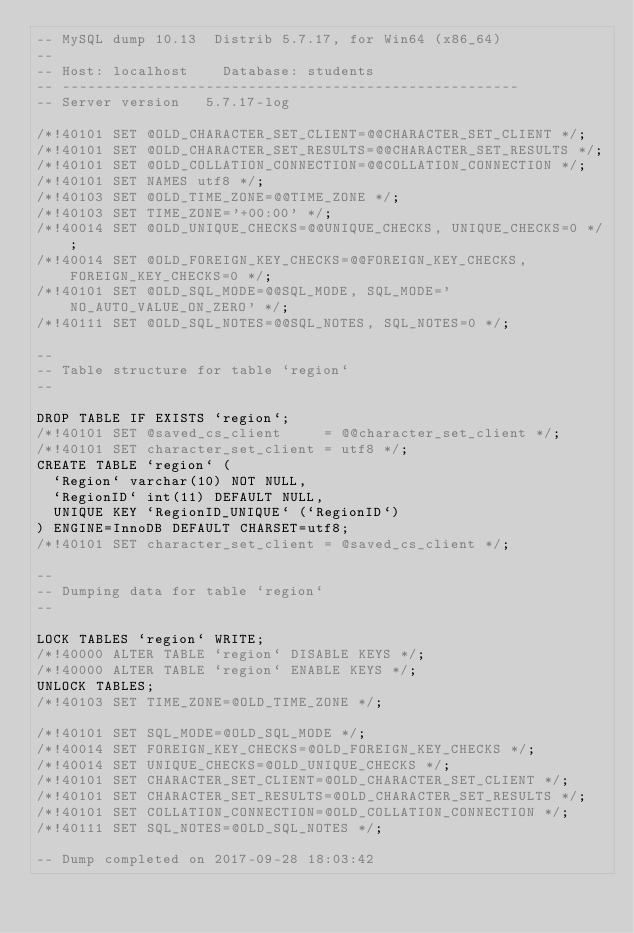<code> <loc_0><loc_0><loc_500><loc_500><_SQL_>-- MySQL dump 10.13  Distrib 5.7.17, for Win64 (x86_64)
--
-- Host: localhost    Database: students
-- ------------------------------------------------------
-- Server version	5.7.17-log

/*!40101 SET @OLD_CHARACTER_SET_CLIENT=@@CHARACTER_SET_CLIENT */;
/*!40101 SET @OLD_CHARACTER_SET_RESULTS=@@CHARACTER_SET_RESULTS */;
/*!40101 SET @OLD_COLLATION_CONNECTION=@@COLLATION_CONNECTION */;
/*!40101 SET NAMES utf8 */;
/*!40103 SET @OLD_TIME_ZONE=@@TIME_ZONE */;
/*!40103 SET TIME_ZONE='+00:00' */;
/*!40014 SET @OLD_UNIQUE_CHECKS=@@UNIQUE_CHECKS, UNIQUE_CHECKS=0 */;
/*!40014 SET @OLD_FOREIGN_KEY_CHECKS=@@FOREIGN_KEY_CHECKS, FOREIGN_KEY_CHECKS=0 */;
/*!40101 SET @OLD_SQL_MODE=@@SQL_MODE, SQL_MODE='NO_AUTO_VALUE_ON_ZERO' */;
/*!40111 SET @OLD_SQL_NOTES=@@SQL_NOTES, SQL_NOTES=0 */;

--
-- Table structure for table `region`
--

DROP TABLE IF EXISTS `region`;
/*!40101 SET @saved_cs_client     = @@character_set_client */;
/*!40101 SET character_set_client = utf8 */;
CREATE TABLE `region` (
  `Region` varchar(10) NOT NULL,
  `RegionID` int(11) DEFAULT NULL,
  UNIQUE KEY `RegionID_UNIQUE` (`RegionID`)
) ENGINE=InnoDB DEFAULT CHARSET=utf8;
/*!40101 SET character_set_client = @saved_cs_client */;

--
-- Dumping data for table `region`
--

LOCK TABLES `region` WRITE;
/*!40000 ALTER TABLE `region` DISABLE KEYS */;
/*!40000 ALTER TABLE `region` ENABLE KEYS */;
UNLOCK TABLES;
/*!40103 SET TIME_ZONE=@OLD_TIME_ZONE */;

/*!40101 SET SQL_MODE=@OLD_SQL_MODE */;
/*!40014 SET FOREIGN_KEY_CHECKS=@OLD_FOREIGN_KEY_CHECKS */;
/*!40014 SET UNIQUE_CHECKS=@OLD_UNIQUE_CHECKS */;
/*!40101 SET CHARACTER_SET_CLIENT=@OLD_CHARACTER_SET_CLIENT */;
/*!40101 SET CHARACTER_SET_RESULTS=@OLD_CHARACTER_SET_RESULTS */;
/*!40101 SET COLLATION_CONNECTION=@OLD_COLLATION_CONNECTION */;
/*!40111 SET SQL_NOTES=@OLD_SQL_NOTES */;

-- Dump completed on 2017-09-28 18:03:42
</code> 